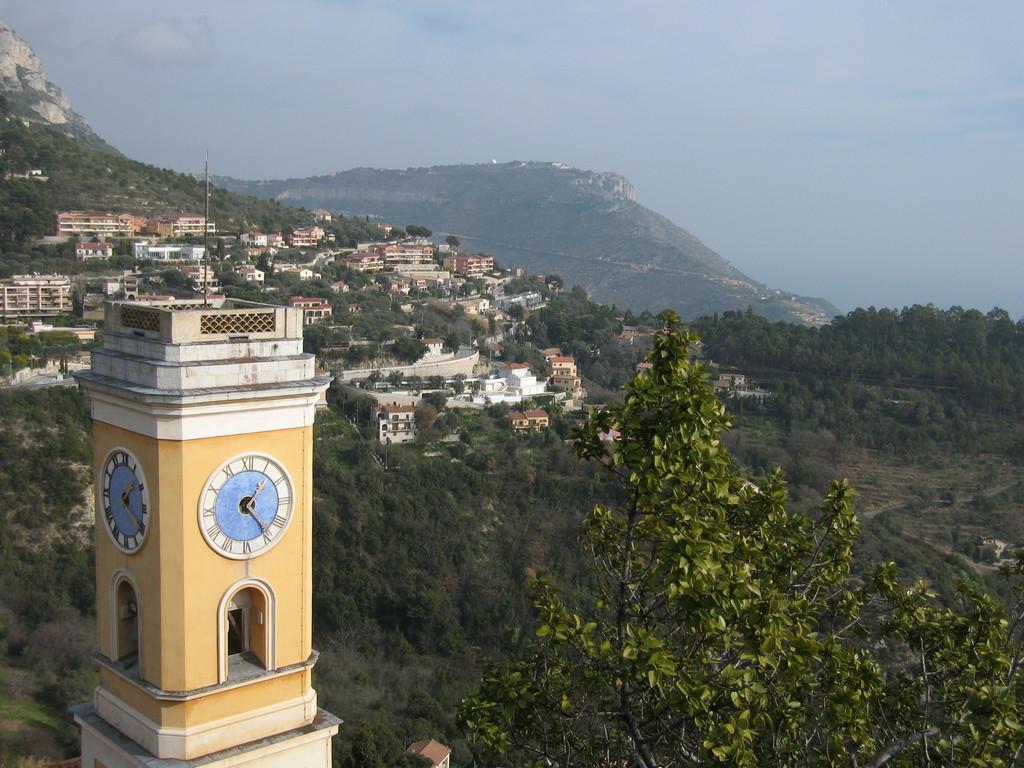Can you describe this image briefly? Here in this picture on the left side we can see a clock tower present and as it is an Aerial view we can see number of trees and plants present and we can see buildings and houses present all over there and in the far we can see mountains covered with grass and plants and we can also see clouds in the sky over there. 